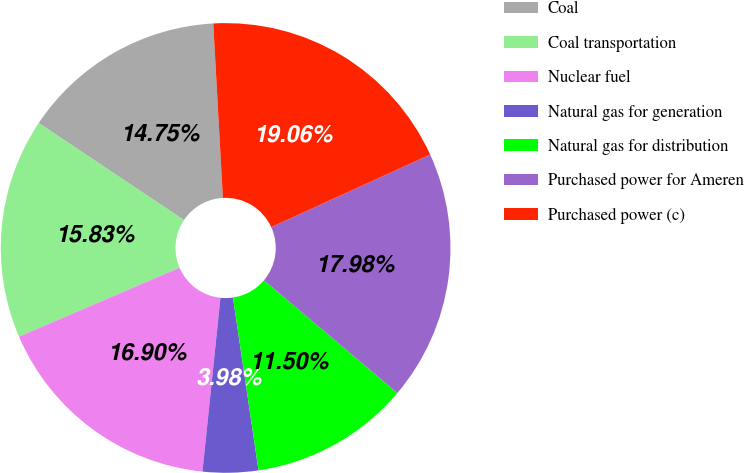<chart> <loc_0><loc_0><loc_500><loc_500><pie_chart><fcel>Coal<fcel>Coal transportation<fcel>Nuclear fuel<fcel>Natural gas for generation<fcel>Natural gas for distribution<fcel>Purchased power for Ameren<fcel>Purchased power (c)<nl><fcel>14.75%<fcel>15.83%<fcel>16.9%<fcel>3.98%<fcel>11.5%<fcel>17.98%<fcel>19.06%<nl></chart> 